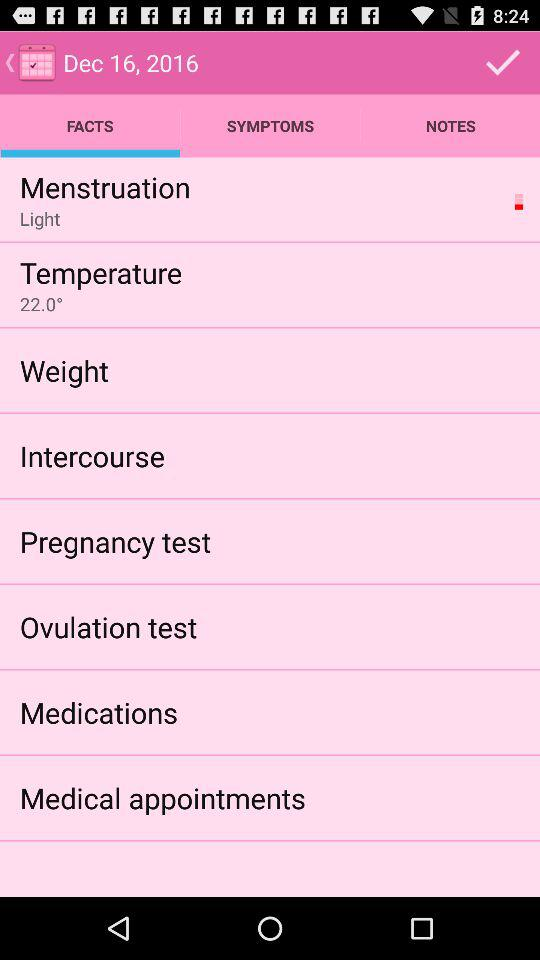What is the date displayed on the screen? The displayed date is December 16, 2016. 